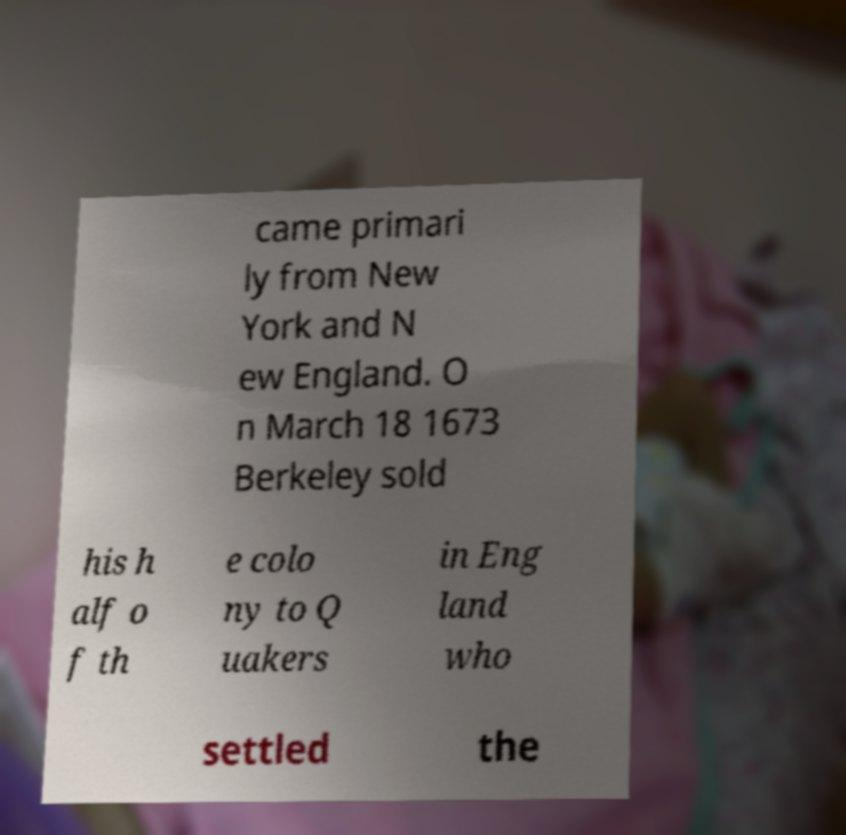Can you read and provide the text displayed in the image?This photo seems to have some interesting text. Can you extract and type it out for me? came primari ly from New York and N ew England. O n March 18 1673 Berkeley sold his h alf o f th e colo ny to Q uakers in Eng land who settled the 